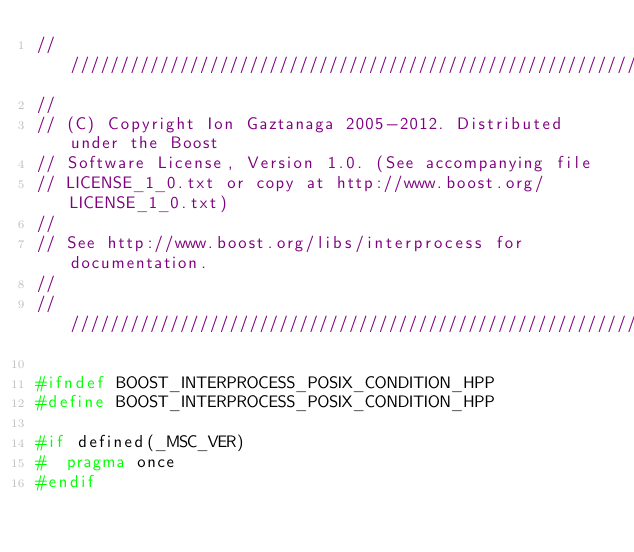Convert code to text. <code><loc_0><loc_0><loc_500><loc_500><_C++_>//////////////////////////////////////////////////////////////////////////////
//
// (C) Copyright Ion Gaztanaga 2005-2012. Distributed under the Boost
// Software License, Version 1.0. (See accompanying file
// LICENSE_1_0.txt or copy at http://www.boost.org/LICENSE_1_0.txt)
//
// See http://www.boost.org/libs/interprocess for documentation.
//
//////////////////////////////////////////////////////////////////////////////

#ifndef BOOST_INTERPROCESS_POSIX_CONDITION_HPP
#define BOOST_INTERPROCESS_POSIX_CONDITION_HPP

#if defined(_MSC_VER)
#  pragma once
#endif
</code> 